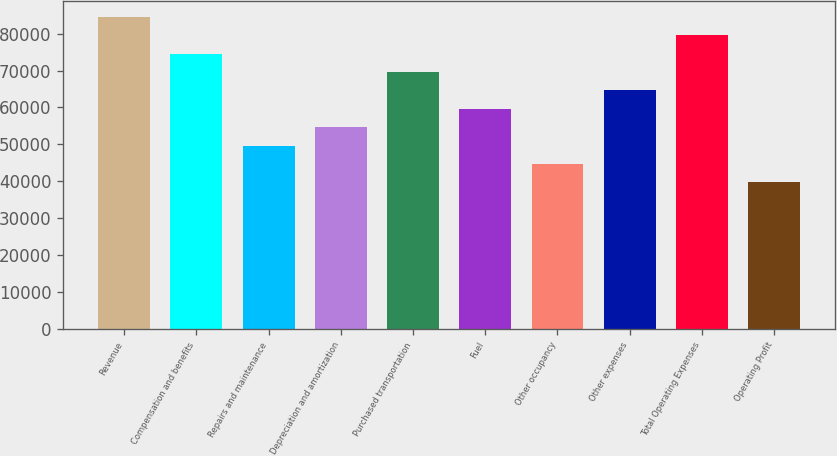Convert chart to OTSL. <chart><loc_0><loc_0><loc_500><loc_500><bar_chart><fcel>Revenue<fcel>Compensation and benefits<fcel>Repairs and maintenance<fcel>Depreciation and amortization<fcel>Purchased transportation<fcel>Fuel<fcel>Other occupancy<fcel>Other expenses<fcel>Total Operating Expenses<fcel>Operating Profit<nl><fcel>84476.1<fcel>74537.8<fcel>49692<fcel>54661.1<fcel>69568.6<fcel>59630.3<fcel>44722.8<fcel>64599.4<fcel>79506.9<fcel>39753.6<nl></chart> 